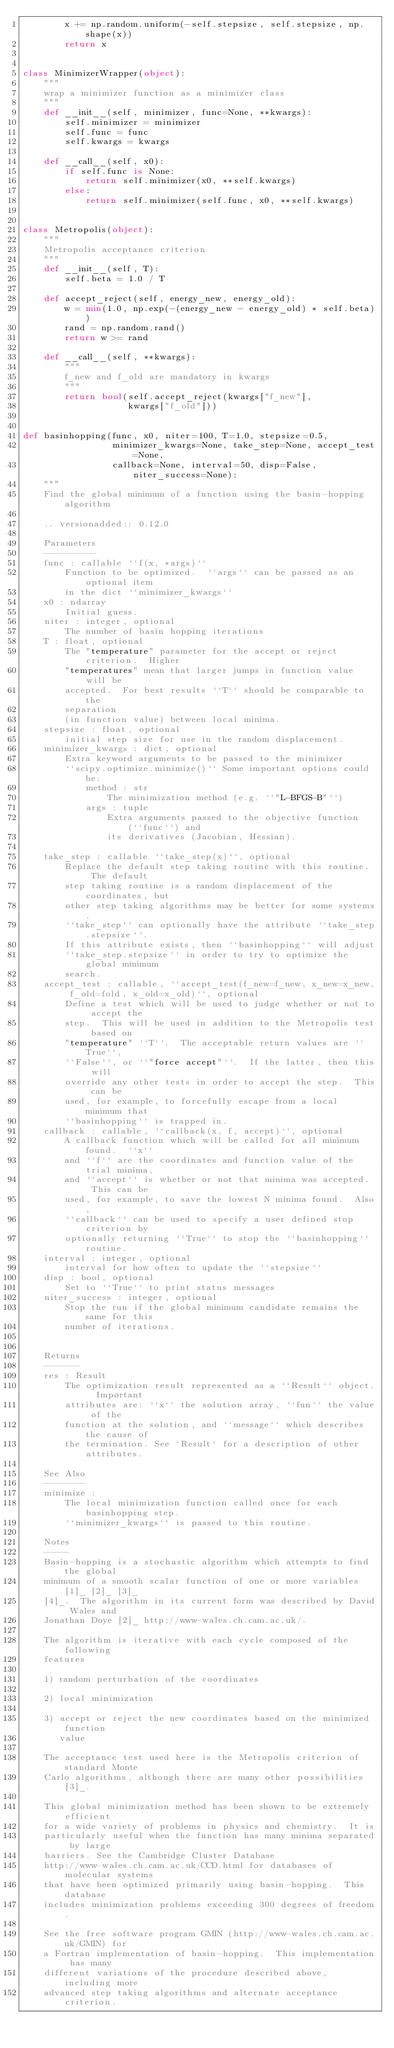Convert code to text. <code><loc_0><loc_0><loc_500><loc_500><_Python_>        x += np.random.uniform(-self.stepsize, self.stepsize, np.shape(x))
        return x


class MinimizerWrapper(object):
    """
    wrap a minimizer function as a minimizer class
    """
    def __init__(self, minimizer, func=None, **kwargs):
        self.minimizer = minimizer
        self.func = func
        self.kwargs = kwargs

    def __call__(self, x0):
        if self.func is None:
            return self.minimizer(x0, **self.kwargs)
        else:
            return self.minimizer(self.func, x0, **self.kwargs)


class Metropolis(object):
    """
    Metropolis acceptance criterion
    """
    def __init__(self, T):
        self.beta = 1.0 / T

    def accept_reject(self, energy_new, energy_old):
        w = min(1.0, np.exp(-(energy_new - energy_old) * self.beta))
        rand = np.random.rand()
        return w >= rand

    def __call__(self, **kwargs):
        """
        f_new and f_old are mandatory in kwargs
        """
        return bool(self.accept_reject(kwargs["f_new"],
                    kwargs["f_old"]))


def basinhopping(func, x0, niter=100, T=1.0, stepsize=0.5,
                 minimizer_kwargs=None, take_step=None, accept_test=None,
                 callback=None, interval=50, disp=False, niter_success=None):
    """
    Find the global minimum of a function using the basin-hopping algorithm

    .. versionadded:: 0.12.0

    Parameters
    ----------
    func : callable ``f(x, *args)``
        Function to be optimized.  ``args`` can be passed as an optional item
        in the dict ``minimizer_kwargs``
    x0 : ndarray
        Initial guess.
    niter : integer, optional
        The number of basin hopping iterations
    T : float, optional
        The "temperature" parameter for the accept or reject criterion.  Higher
        "temperatures" mean that larger jumps in function value will be
        accepted.  For best results ``T`` should be comparable to the
        separation
        (in function value) between local minima.
    stepsize : float, optional
        initial step size for use in the random displacement.
    minimizer_kwargs : dict, optional
        Extra keyword arguments to be passed to the minimizer
        ``scipy.optimize.minimize()`` Some important options could be:
            method : str
                The minimization method (e.g. ``"L-BFGS-B"``)
            args : tuple
                Extra arguments passed to the objective function (``func``) and
                its derivatives (Jacobian, Hessian).

    take_step : callable ``take_step(x)``, optional
        Replace the default step taking routine with this routine.  The default
        step taking routine is a random displacement of the coordinates, but
        other step taking algorithms may be better for some systems.
        ``take_step`` can optionally have the attribute ``take_step.stepsize``.
        If this attribute exists, then ``basinhopping`` will adjust
        ``take_step.stepsize`` in order to try to optimize the global minimum
        search.
    accept_test : callable, ``accept_test(f_new=f_new, x_new=x_new, f_old=fold, x_old=x_old)``, optional
        Define a test which will be used to judge whether or not to accept the
        step.  This will be used in addition to the Metropolis test based on
        "temperature" ``T``.  The acceptable return values are ``True``,
        ``False``, or ``"force accept"``.  If the latter, then this will
        override any other tests in order to accept the step.  This can be
        used, for example, to forcefully escape from a local minimum that
        ``basinhopping`` is trapped in.
    callback : callable, ``callback(x, f, accept)``, optional
        A callback function which will be called for all minimum found.  ``x``
        and ``f`` are the coordinates and function value of the trial minima,
        and ``accept`` is whether or not that minima was accepted.  This can be
        used, for example, to save the lowest N minima found.  Also,
        ``callback`` can be used to specify a user defined stop criterion by
        optionally returning ``True`` to stop the ``basinhopping`` routine.
    interval : integer, optional
        interval for how often to update the ``stepsize``
    disp : bool, optional
        Set to ``True`` to print status messages
    niter_success : integer, optional
        Stop the run if the global minimum candidate remains the same for this
        number of iterations.


    Returns
    -------
    res : Result
        The optimization result represented as a ``Result`` object.  Important
        attributes are: ``x`` the solution array, ``fun`` the value of the
        function at the solution, and ``message`` which describes the cause of
        the termination. See `Result` for a description of other attributes.

    See Also
    --------
    minimize :
        The local minimization function called once for each basinhopping step.
        ``minimizer_kwargs`` is passed to this routine.

    Notes
    -----
    Basin-hopping is a stochastic algorithm which attempts to find the global
    minimum of a smooth scalar function of one or more variables [1]_ [2]_ [3]_
    [4]_.  The algorithm in its current form was described by David Wales and
    Jonathan Doye [2]_ http://www-wales.ch.cam.ac.uk/.

    The algorithm is iterative with each cycle composed of the following
    features

    1) random perturbation of the coordinates

    2) local minimization

    3) accept or reject the new coordinates based on the minimized function
       value

    The acceptance test used here is the Metropolis criterion of standard Monte
    Carlo algorithms, although there are many other possibilities [3]_.

    This global minimization method has been shown to be extremely efficient
    for a wide variety of problems in physics and chemistry.  It is
    particularly useful when the function has many minima separated by large
    barriers. See the Cambridge Cluster Database
    http://www-wales.ch.cam.ac.uk/CCD.html for databases of molecular systems
    that have been optimized primarily using basin-hopping.  This database
    includes minimization problems exceeding 300 degrees of freedom.

    See the free software program GMIN (http://www-wales.ch.cam.ac.uk/GMIN) for
    a Fortran implementation of basin-hopping.  This implementation has many
    different variations of the procedure described above, including more
    advanced step taking algorithms and alternate acceptance criterion.
</code> 